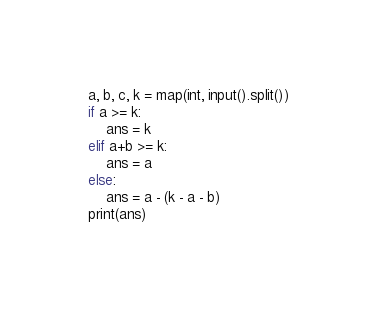<code> <loc_0><loc_0><loc_500><loc_500><_Python_>a, b, c, k = map(int, input().split())
if a >= k:
    ans = k
elif a+b >= k:
    ans = a
else:
    ans = a - (k - a - b)
print(ans)</code> 